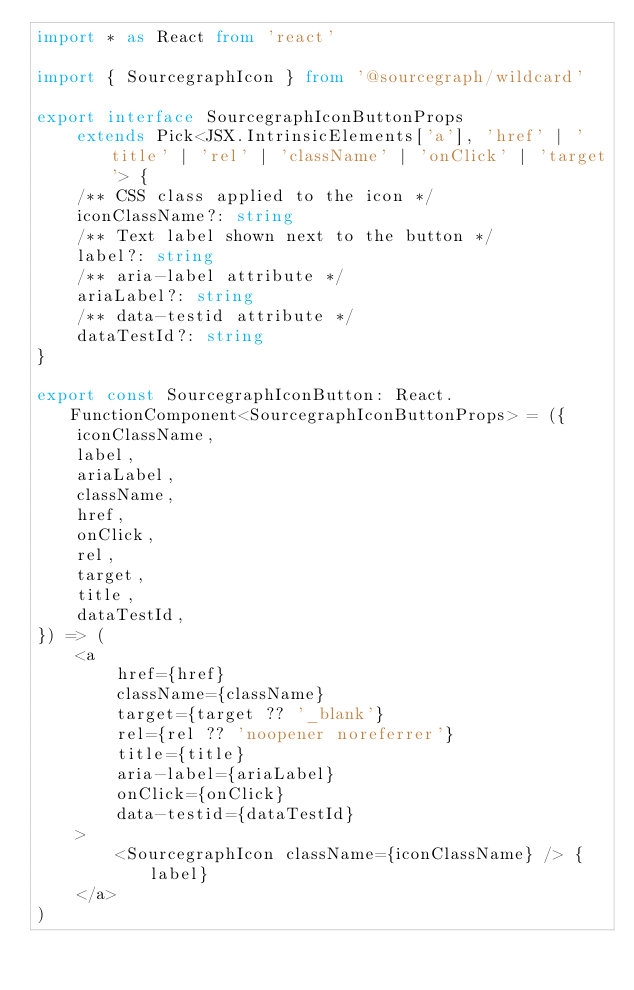Convert code to text. <code><loc_0><loc_0><loc_500><loc_500><_TypeScript_>import * as React from 'react'

import { SourcegraphIcon } from '@sourcegraph/wildcard'

export interface SourcegraphIconButtonProps
    extends Pick<JSX.IntrinsicElements['a'], 'href' | 'title' | 'rel' | 'className' | 'onClick' | 'target'> {
    /** CSS class applied to the icon */
    iconClassName?: string
    /** Text label shown next to the button */
    label?: string
    /** aria-label attribute */
    ariaLabel?: string
    /** data-testid attribute */
    dataTestId?: string
}

export const SourcegraphIconButton: React.FunctionComponent<SourcegraphIconButtonProps> = ({
    iconClassName,
    label,
    ariaLabel,
    className,
    href,
    onClick,
    rel,
    target,
    title,
    dataTestId,
}) => (
    <a
        href={href}
        className={className}
        target={target ?? '_blank'}
        rel={rel ?? 'noopener noreferrer'}
        title={title}
        aria-label={ariaLabel}
        onClick={onClick}
        data-testid={dataTestId}
    >
        <SourcegraphIcon className={iconClassName} /> {label}
    </a>
)
</code> 